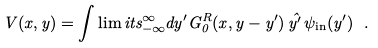Convert formula to latex. <formula><loc_0><loc_0><loc_500><loc_500>V ( x , y ) = \int \lim i t s _ { - \infty } ^ { \infty } d y ^ { \prime } G ^ { R } _ { 0 } ( x , y - y ^ { \prime } ) \, \hat { y ^ { \prime } } \, \psi _ { \text {in} } ( y ^ { \prime } ) \ .</formula> 